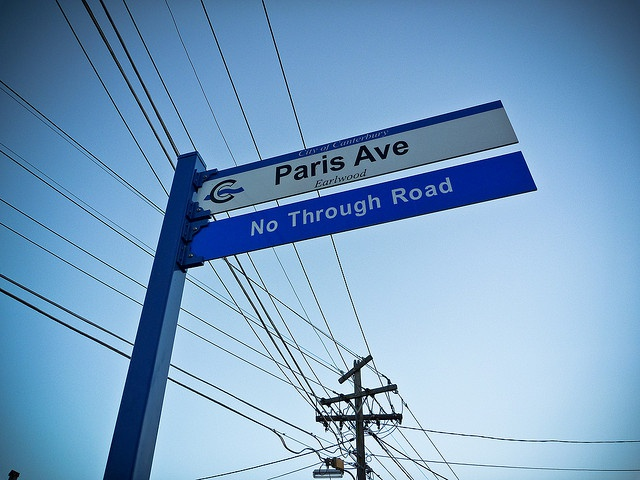Describe the objects in this image and their specific colors. I can see various objects in this image with different colors. 